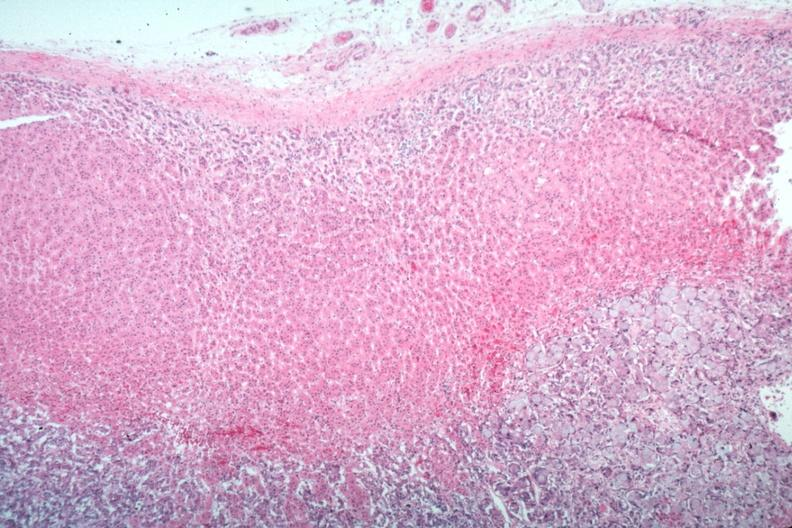s endocrine present?
Answer the question using a single word or phrase. Yes 